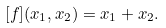<formula> <loc_0><loc_0><loc_500><loc_500>[ f ] ( x _ { 1 } , x _ { 2 } ) = x _ { 1 } + x _ { 2 } .</formula> 